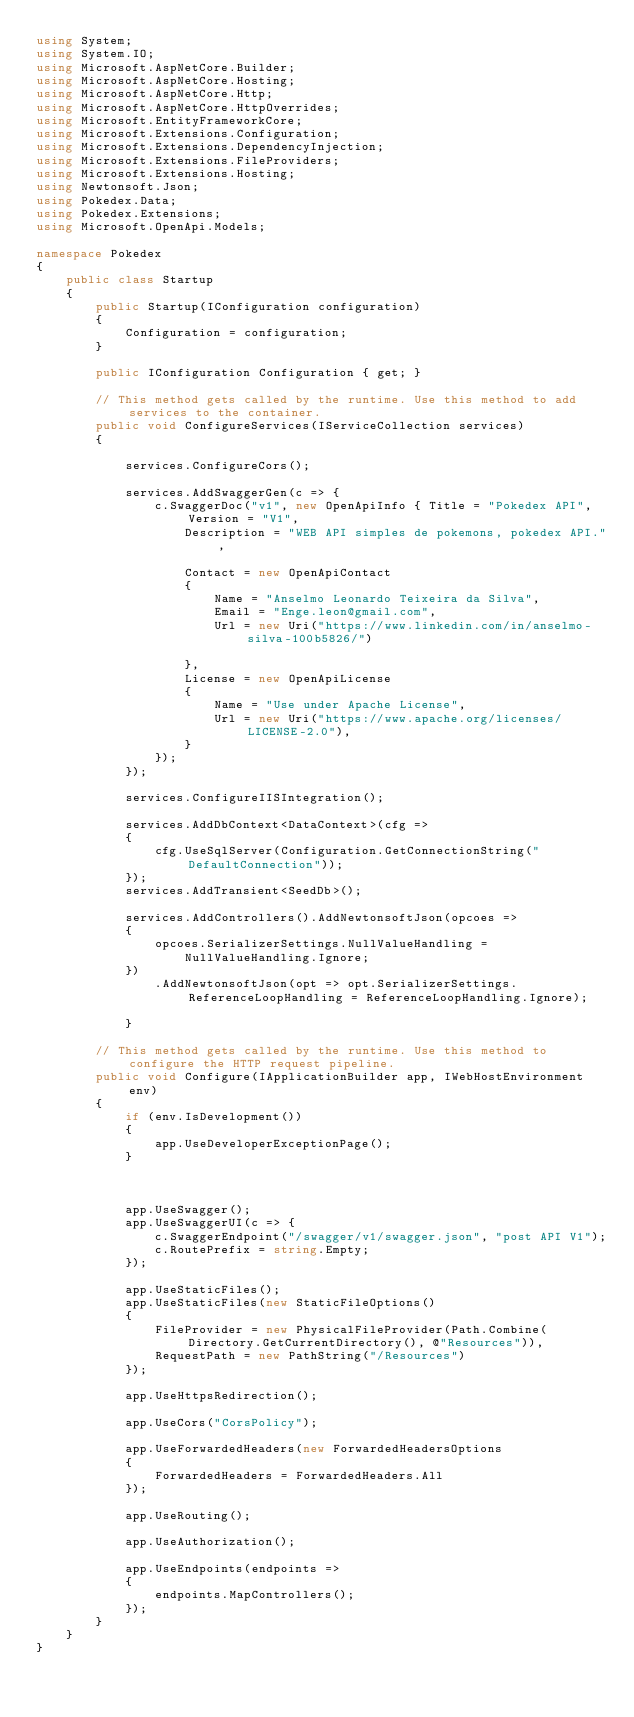Convert code to text. <code><loc_0><loc_0><loc_500><loc_500><_C#_>using System;
using System.IO;
using Microsoft.AspNetCore.Builder;
using Microsoft.AspNetCore.Hosting;
using Microsoft.AspNetCore.Http;
using Microsoft.AspNetCore.HttpOverrides;
using Microsoft.EntityFrameworkCore;
using Microsoft.Extensions.Configuration;
using Microsoft.Extensions.DependencyInjection;
using Microsoft.Extensions.FileProviders;
using Microsoft.Extensions.Hosting;
using Newtonsoft.Json;
using Pokedex.Data;
using Pokedex.Extensions;
using Microsoft.OpenApi.Models;

namespace Pokedex
{
    public class Startup
    {
        public Startup(IConfiguration configuration)
        {
            Configuration = configuration;
        }

        public IConfiguration Configuration { get; }

        // This method gets called by the runtime. Use this method to add services to the container.
        public void ConfigureServices(IServiceCollection services)
        {

            services.ConfigureCors();

            services.AddSwaggerGen(c => {
                c.SwaggerDoc("v1", new OpenApiInfo { Title = "Pokedex API", Version = "V1",
                    Description = "WEB API simples de pokemons, pokedex API.",
                    
                    Contact = new OpenApiContact
                    {
                        Name = "Anselmo Leonardo Teixeira da Silva",
                        Email = "Enge.leon@gmail.com",
                        Url = new Uri("https://www.linkedin.com/in/anselmo-silva-100b5826/")
                        
                    },
                    License = new OpenApiLicense
                    {
                        Name = "Use under Apache License",
                        Url = new Uri("https://www.apache.org/licenses/LICENSE-2.0"),
                    }
                });
            });

            services.ConfigureIISIntegration();

            services.AddDbContext<DataContext>(cfg =>
            {
                cfg.UseSqlServer(Configuration.GetConnectionString("DefaultConnection"));
            });
            services.AddTransient<SeedDb>();
            
            services.AddControllers().AddNewtonsoftJson(opcoes =>
            {
                opcoes.SerializerSettings.NullValueHandling =
                    NullValueHandling.Ignore;
            })
                .AddNewtonsoftJson(opt => opt.SerializerSettings.ReferenceLoopHandling = ReferenceLoopHandling.Ignore);

            }

        // This method gets called by the runtime. Use this method to configure the HTTP request pipeline.
        public void Configure(IApplicationBuilder app, IWebHostEnvironment env)
        {
            if (env.IsDevelopment())
            {
                app.UseDeveloperExceptionPage();
            }

            

            app.UseSwagger();
            app.UseSwaggerUI(c => {
                c.SwaggerEndpoint("/swagger/v1/swagger.json", "post API V1");
                c.RoutePrefix = string.Empty;
            });

            app.UseStaticFiles(); 
            app.UseStaticFiles(new StaticFileOptions()
            {
                FileProvider = new PhysicalFileProvider(Path.Combine(Directory.GetCurrentDirectory(), @"Resources")),
                RequestPath = new PathString("/Resources")
            });

            app.UseHttpsRedirection();

            app.UseCors("CorsPolicy");

            app.UseForwardedHeaders(new ForwardedHeadersOptions
            {
                ForwardedHeaders = ForwardedHeaders.All
            });

            app.UseRouting();

            app.UseAuthorization();

            app.UseEndpoints(endpoints =>
            {
                endpoints.MapControllers();
            });
        }
    }
}
</code> 